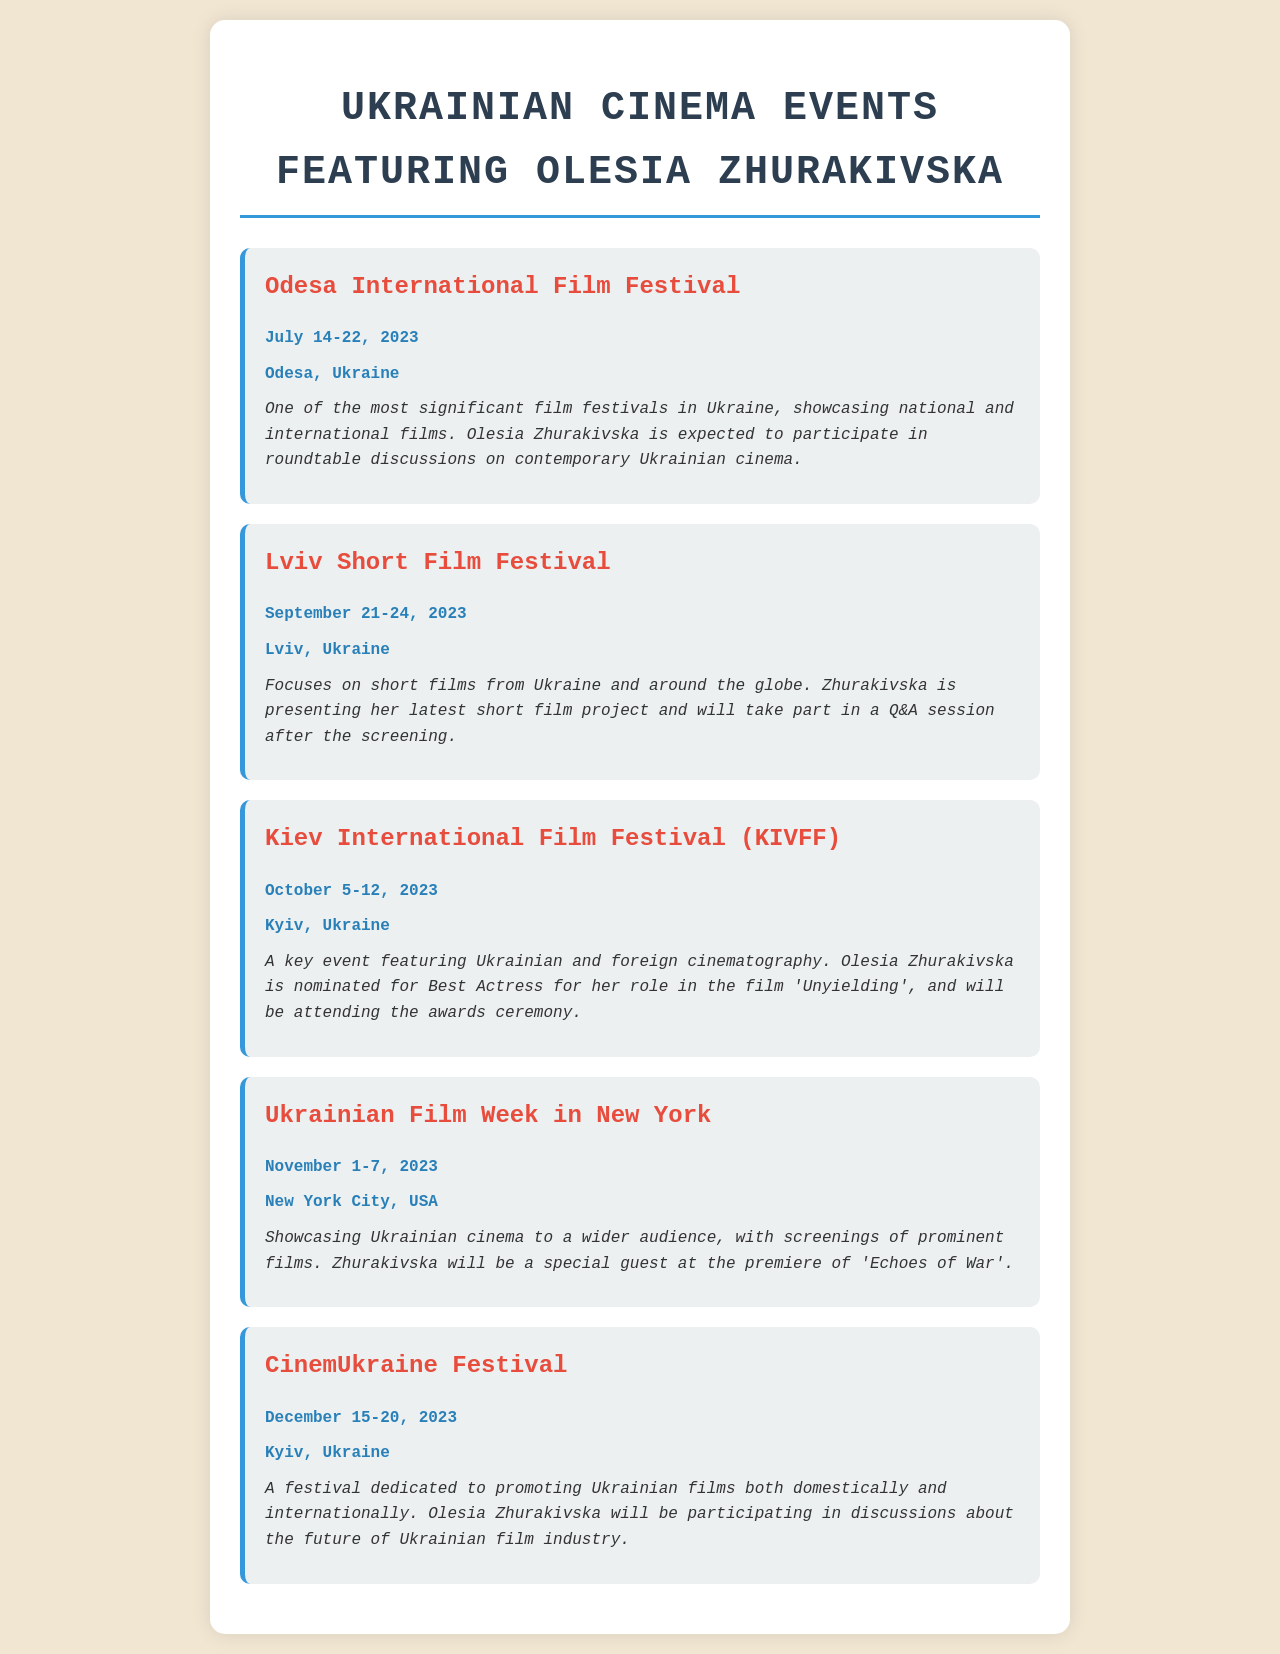What is the date range for the Odesa International Film Festival? The document states that the Odesa International Film Festival takes place from July 14 to July 22, 2023.
Answer: July 14-22, 2023 Where is the Lviv Short Film Festival held? According to the document, the Lviv Short Film Festival is located in Lviv, Ukraine.
Answer: Lviv, Ukraine What role is Olesia Zhurakivska nominated for at the Kiev International Film Festival? The document mentions that she is nominated for Best Actress for her role in the film 'Unyielding'.
Answer: Best Actress When will the Ukrainian Film Week in New York take place? The document indicates that the Ukrainian Film Week in New York will occur from November 1 to November 7, 2023.
Answer: November 1-7, 2023 Which festival features discussions about the future of the Ukrainian film industry? The document states that the CinemUkraine Festival includes discussions about the future of the Ukrainian film industry.
Answer: CinemUkraine Festival What is the main focus of the Lviv Short Film Festival? The document describes that the Lviv Short Film Festival focuses on short films from Ukraine and around the globe.
Answer: Short films Who is attending the premiere of 'Echoes of War'? According to the document, Olesia Zhurakivska will be a special guest at the premiere.
Answer: Olesia Zhurakivska How long does the CinemUkraine Festival last? The document shows that the CinemUkraine Festival lasts for six days.
Answer: Six days What event will Olesia Zhurakivska be participating in roundtable discussions? The document mentions that she will participate in roundtable discussions at the Odesa International Film Festival.
Answer: Odesa International Film Festival 